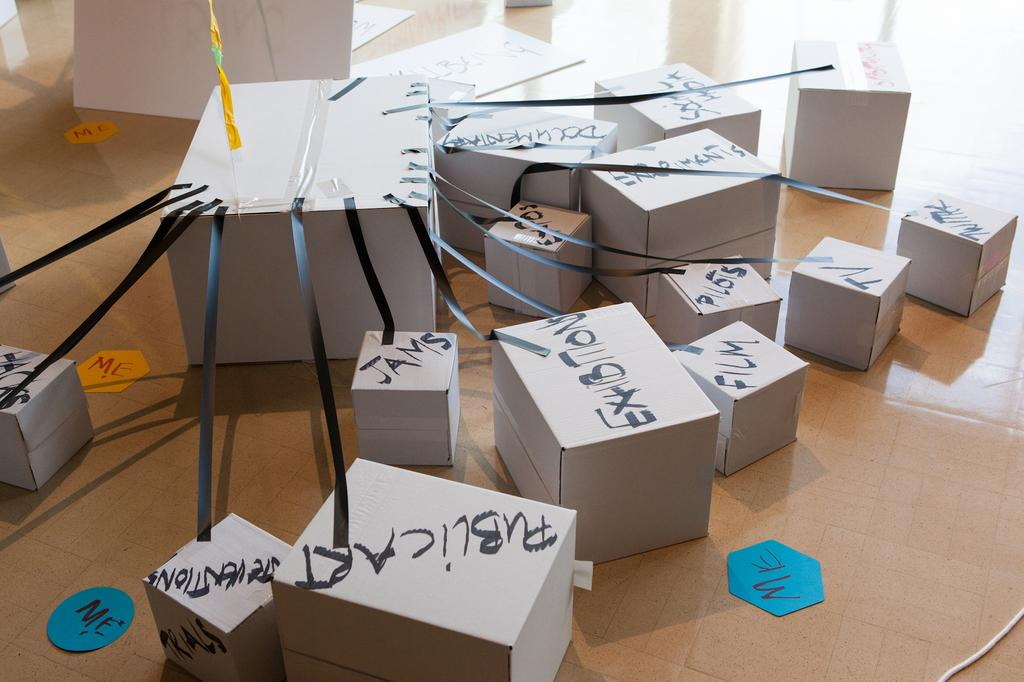Provide a one-sentence caption for the provided image. One large white box connected to a series of other boxes meant to show the connection between a person and activities or things. 